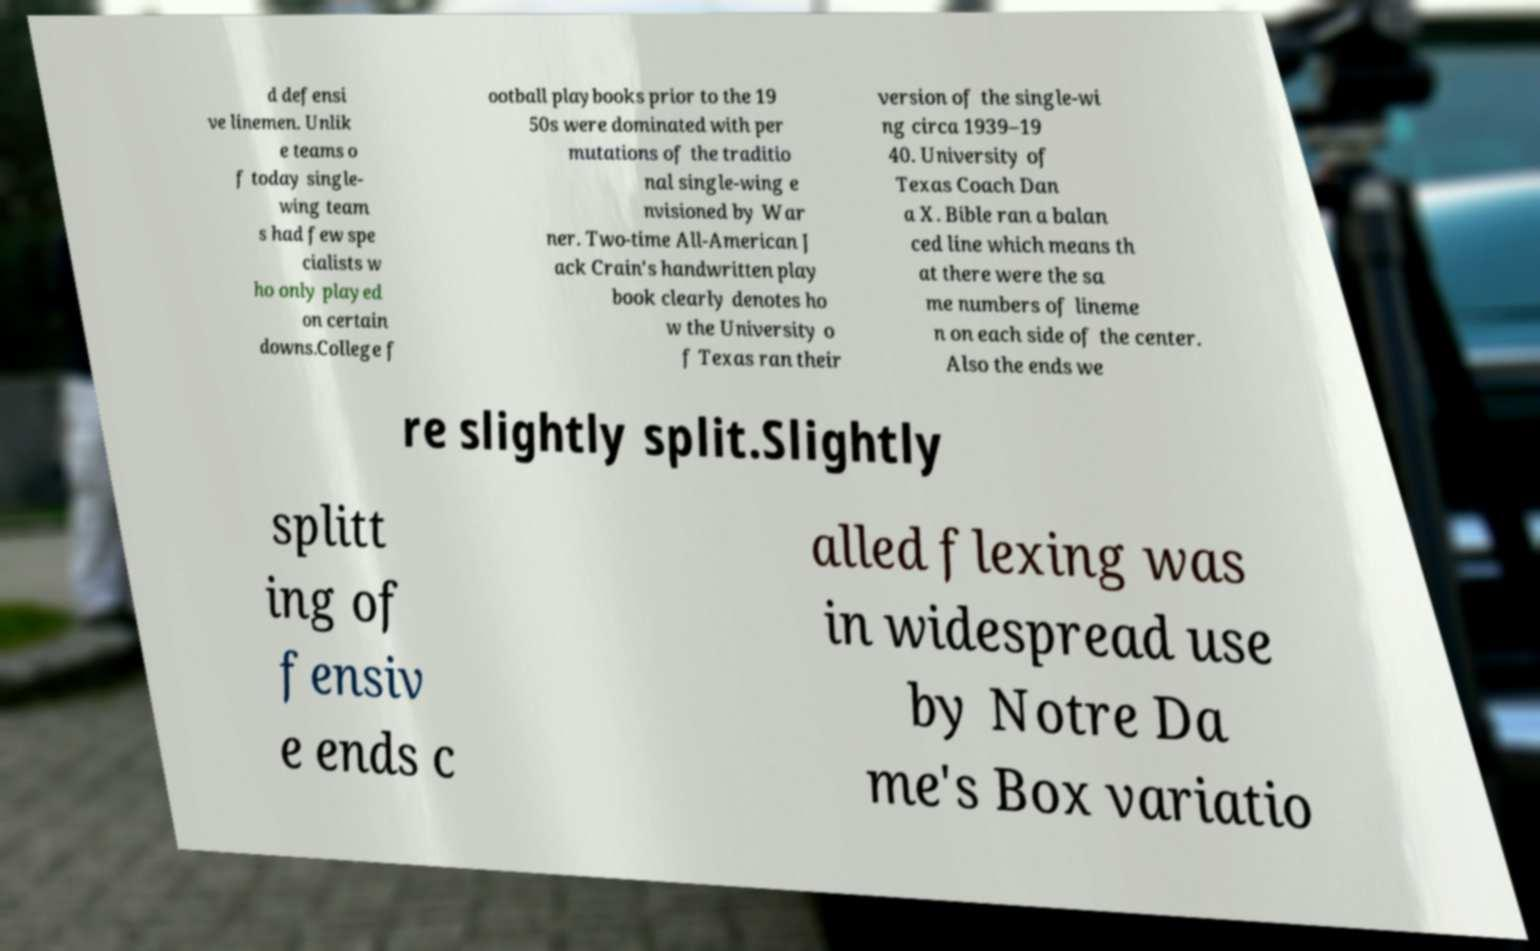What messages or text are displayed in this image? I need them in a readable, typed format. d defensi ve linemen. Unlik e teams o f today single- wing team s had few spe cialists w ho only played on certain downs.College f ootball playbooks prior to the 19 50s were dominated with per mutations of the traditio nal single-wing e nvisioned by War ner. Two-time All-American J ack Crain's handwritten play book clearly denotes ho w the University o f Texas ran their version of the single-wi ng circa 1939–19 40. University of Texas Coach Dan a X. Bible ran a balan ced line which means th at there were the sa me numbers of lineme n on each side of the center. Also the ends we re slightly split.Slightly splitt ing of fensiv e ends c alled flexing was in widespread use by Notre Da me's Box variatio 